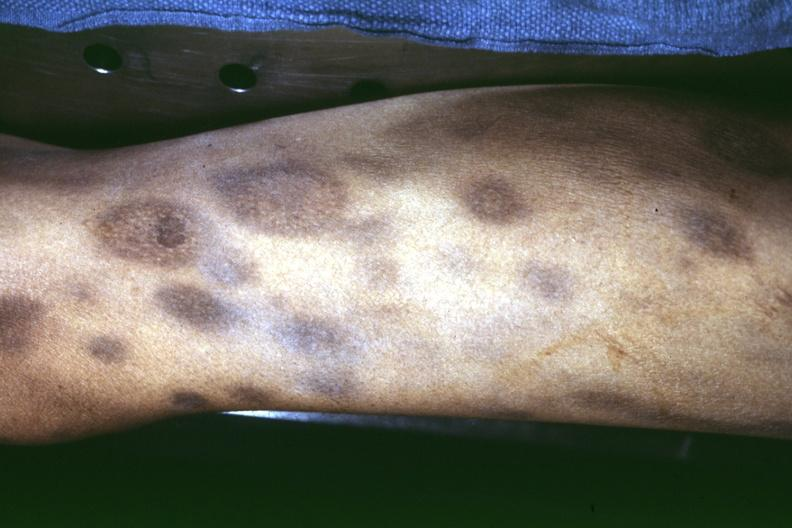what does this image show?
Answer the question using a single word or phrase. Thigh at autopsy ecchymoses with necrotizing centers 